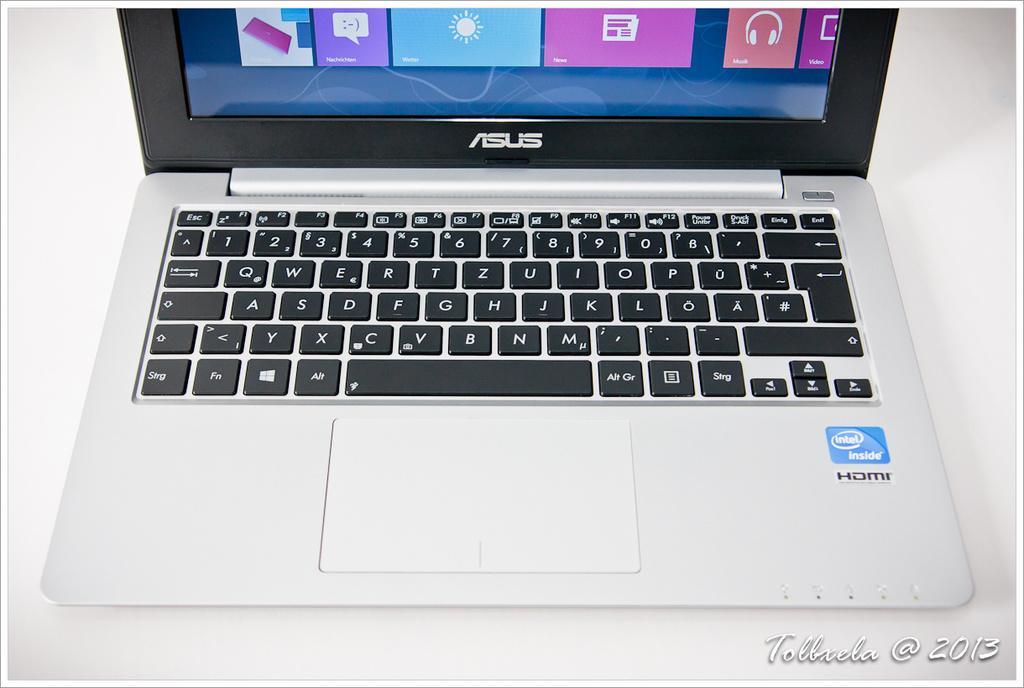Could you give a brief overview of what you see in this image? In this image I can see a laptop which is white and black in color. I can see its screen is blue,orange, white and purple in color. I can see the laptop is on the white colored surface. 